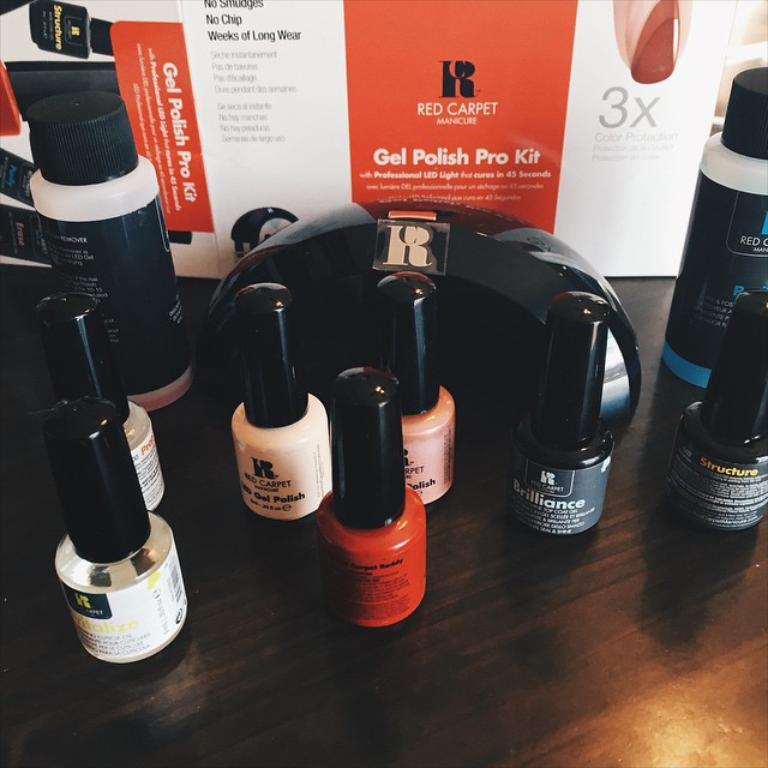Provide a one-sentence caption for the provided image. The product being features on the table is nail polish from the Red Carpet Gel Polish Pro Kit. 